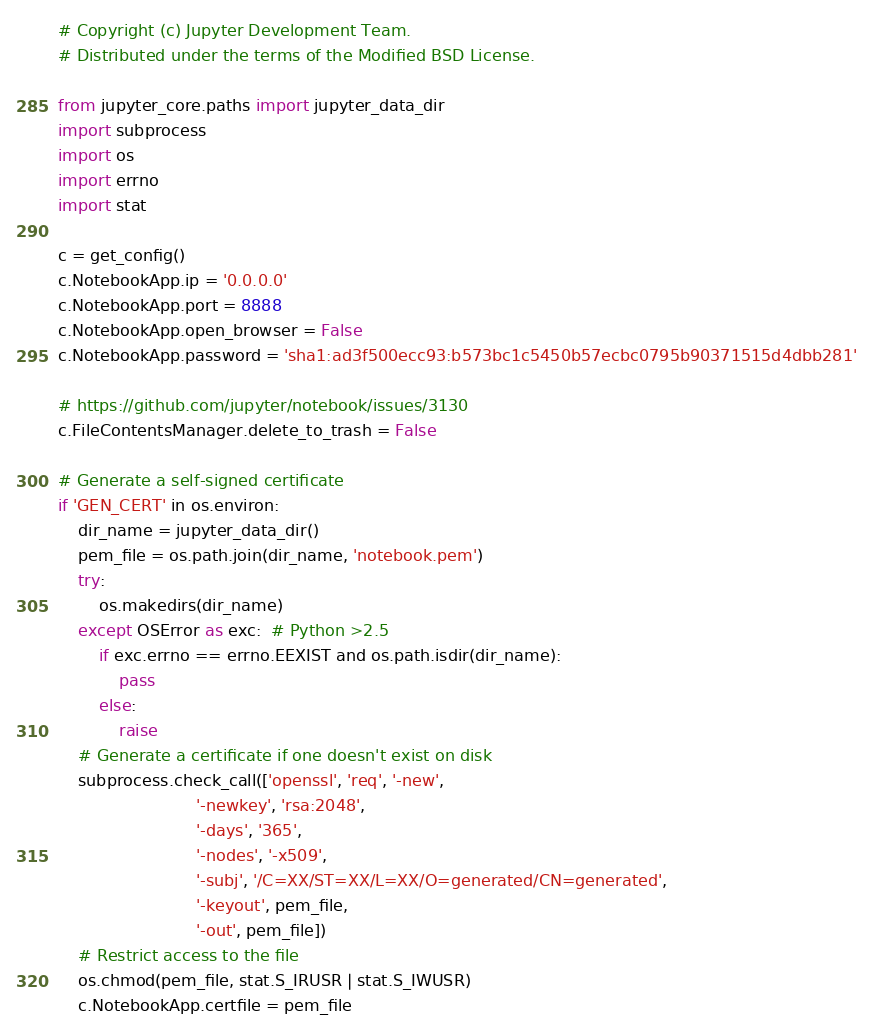Convert code to text. <code><loc_0><loc_0><loc_500><loc_500><_Python_># Copyright (c) Jupyter Development Team.
# Distributed under the terms of the Modified BSD License.

from jupyter_core.paths import jupyter_data_dir
import subprocess
import os
import errno
import stat

c = get_config()
c.NotebookApp.ip = '0.0.0.0'
c.NotebookApp.port = 8888
c.NotebookApp.open_browser = False
c.NotebookApp.password = 'sha1:ad3f500ecc93:b573bc1c5450b57ecbc0795b90371515d4dbb281'

# https://github.com/jupyter/notebook/issues/3130
c.FileContentsManager.delete_to_trash = False

# Generate a self-signed certificate
if 'GEN_CERT' in os.environ:
    dir_name = jupyter_data_dir()
    pem_file = os.path.join(dir_name, 'notebook.pem')
    try:
        os.makedirs(dir_name)
    except OSError as exc:  # Python >2.5
        if exc.errno == errno.EEXIST and os.path.isdir(dir_name):
            pass
        else:
            raise
    # Generate a certificate if one doesn't exist on disk
    subprocess.check_call(['openssl', 'req', '-new',
                           '-newkey', 'rsa:2048',
                           '-days', '365',
                           '-nodes', '-x509',
                           '-subj', '/C=XX/ST=XX/L=XX/O=generated/CN=generated',
                           '-keyout', pem_file,
                           '-out', pem_file])
    # Restrict access to the file
    os.chmod(pem_file, stat.S_IRUSR | stat.S_IWUSR)
    c.NotebookApp.certfile = pem_file
</code> 